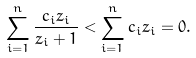<formula> <loc_0><loc_0><loc_500><loc_500>\sum _ { i = 1 } ^ { n } \frac { c _ { i } z _ { i } } { z _ { i } + 1 } < \sum _ { i = 1 } ^ { n } c _ { i } z _ { i } = 0 .</formula> 